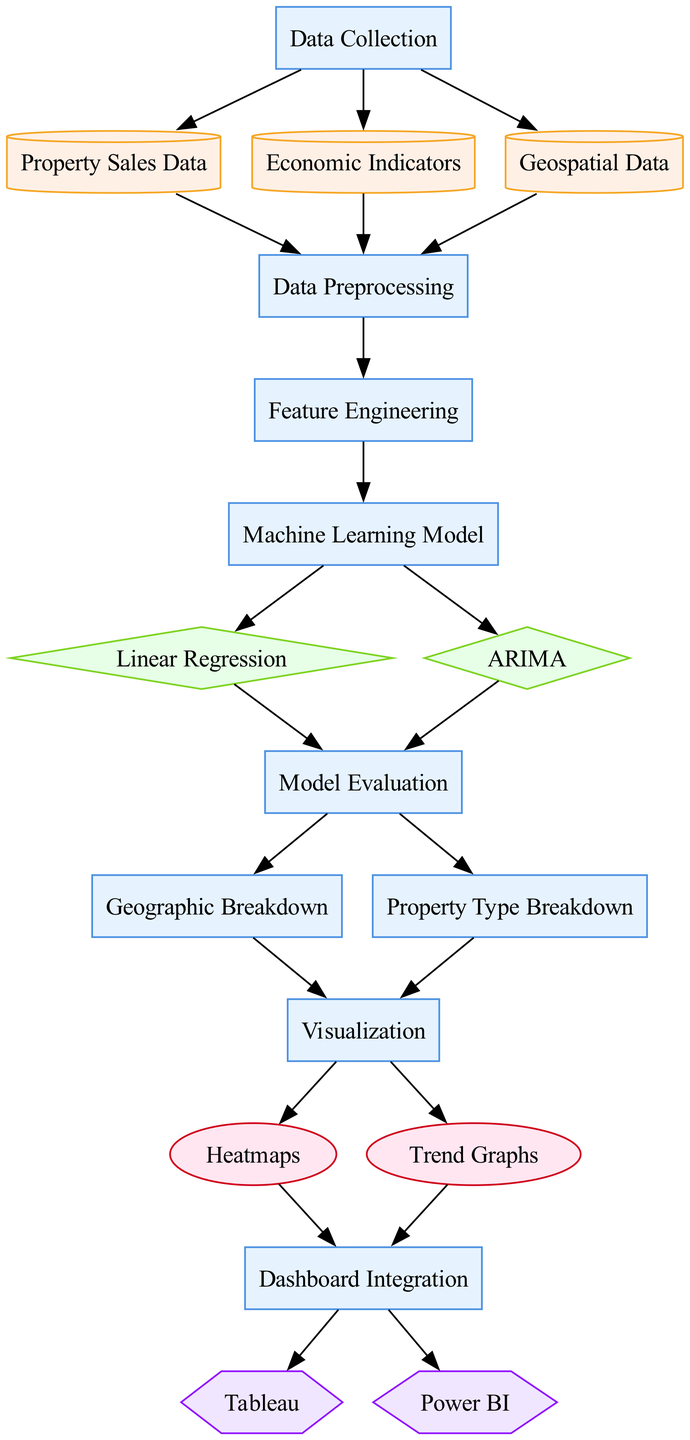What is the first step in the process? The diagram indicates that the first step is "Data Collection" which is denoted as the initial process in the workflow.
Answer: Data Collection How many types of data sources are there? In the diagram, there are three types of data sources: Property Sales Data, Economic Indicators, and Geospatial Data.
Answer: Three What type of model is used for predicting future property values? The diagram specifies that "Linear Regression" is the model used for predicting future property values, which is a standard method for regression analysis.
Answer: Linear Regression Which process follows "Data Preprocessing"? The diagram shows that after "Data Preprocessing", the next process is "Feature Engineering", indicating the flow of tasks.
Answer: Feature Engineering How many visualizations are generated from the model output? The diagram presents two visualizations: "Heatmaps" and "Trend Graphs" which represent different ways to visualize the modeled data.
Answer: Two Which tools are used for displaying visual insights? The diagram mentions two tools used for displaying insights: "Tableau" and "Power BI", both of which are popular in data visualization.
Answer: Tableau and Power BI What is the final step in the diagram process? The last process in the flow is "Dashboard Integration", which integrates visualizations into business intelligence platforms.
Answer: Dashboard Integration What processes lead into "Machine Learning Model"? The processes that lead into "Machine Learning Model" are "Data Preprocessing" and "Feature Engineering", indicating that these two are prerequisites for building the model.
Answer: Data Preprocessing and Feature Engineering Which model is used to analyze time series data? The diagram indicates that "ARIMA", a model specifically designed for analyzing time series data, is employed for this purpose.
Answer: ARIMA 